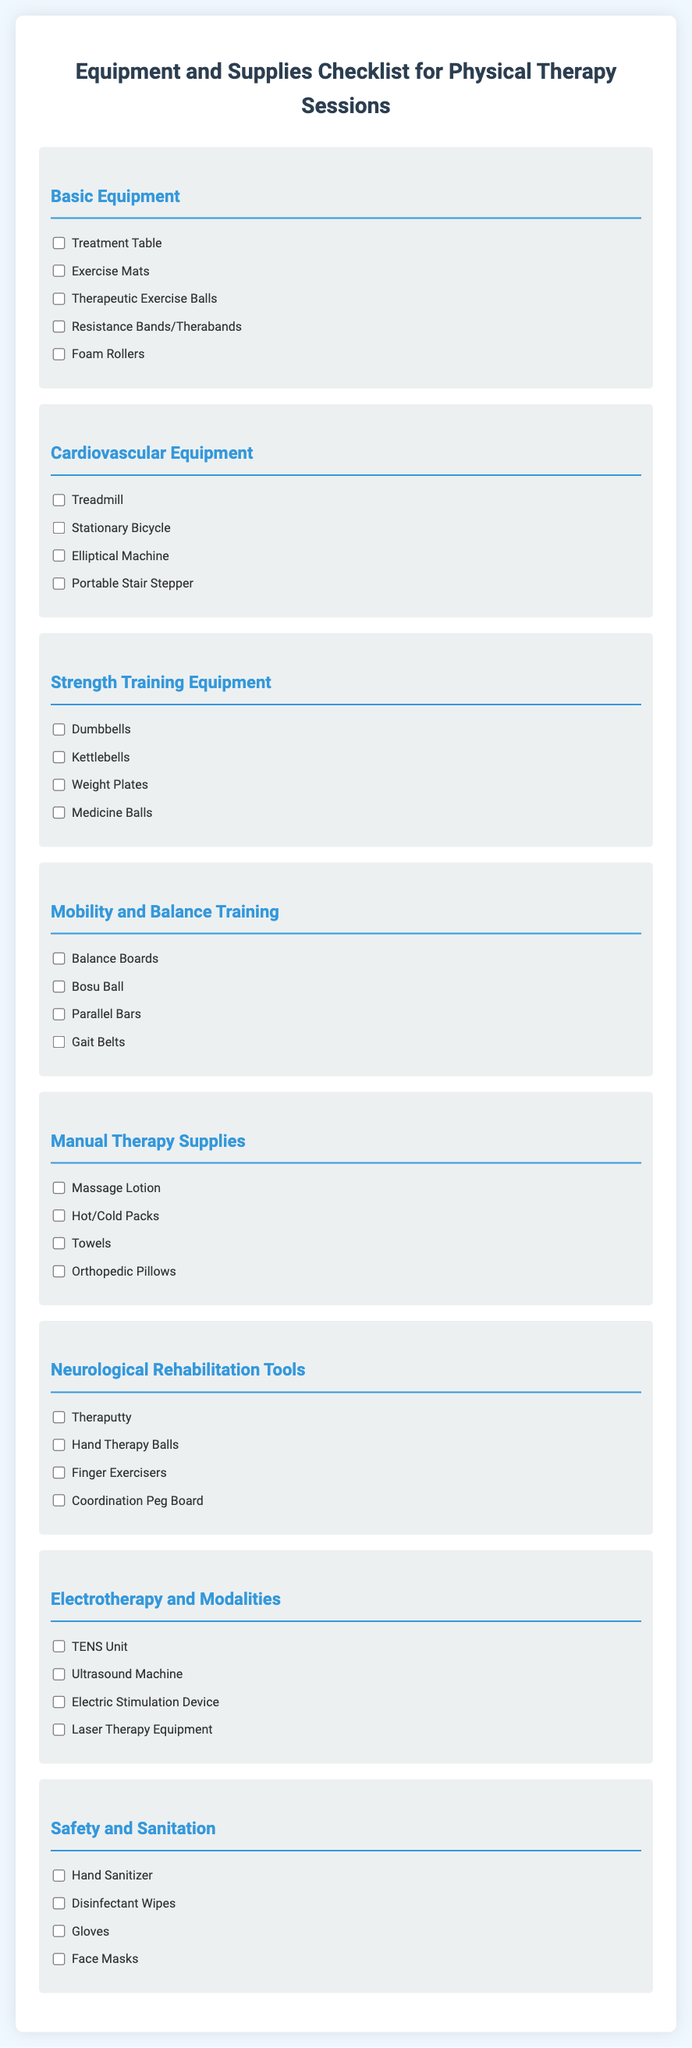What is the first item listed under Basic Equipment? The first item listed under Basic Equipment in the checklist is the Treatment Table.
Answer: Treatment Table How many items are listed under Mobility and Balance Training? There are four items listed under Mobility and Balance Training in the checklist.
Answer: 4 Which equipment is used for cardiovascular training and described in the document? The equipment used for cardiovascular training includes Treadmill, Stationary Bicycle, Elliptical Machine, and Portable Stair Stepper.
Answer: 4 What item is included in the Manual Therapy Supplies section? The item included in the Manual Therapy Supplies section is Massage Lotion.
Answer: Massage Lotion How many types of Neurological Rehabilitation Tools are mentioned? There are four types of Neurological Rehabilitation Tools mentioned in the checklist.
Answer: 4 What equipment is used for strength training? The equipment used for strength training includes Dumbbells, Kettlebells, Weight Plates, and Medicine Balls.
Answer: 4 Which section contains TENS Unit? The TENS Unit is found in the Electrotherapy and Modalities section of the checklist.
Answer: Electrotherapy and Modalities What is one of the safety supplies listed in the Safety and Sanitation section? One of the safety supplies listed in the Safety and Sanitation section is Hand Sanitizer.
Answer: Hand Sanitizer How many items are in the checklist for Basic Equipment? There are five items in the checklist for Basic Equipment.
Answer: 5 